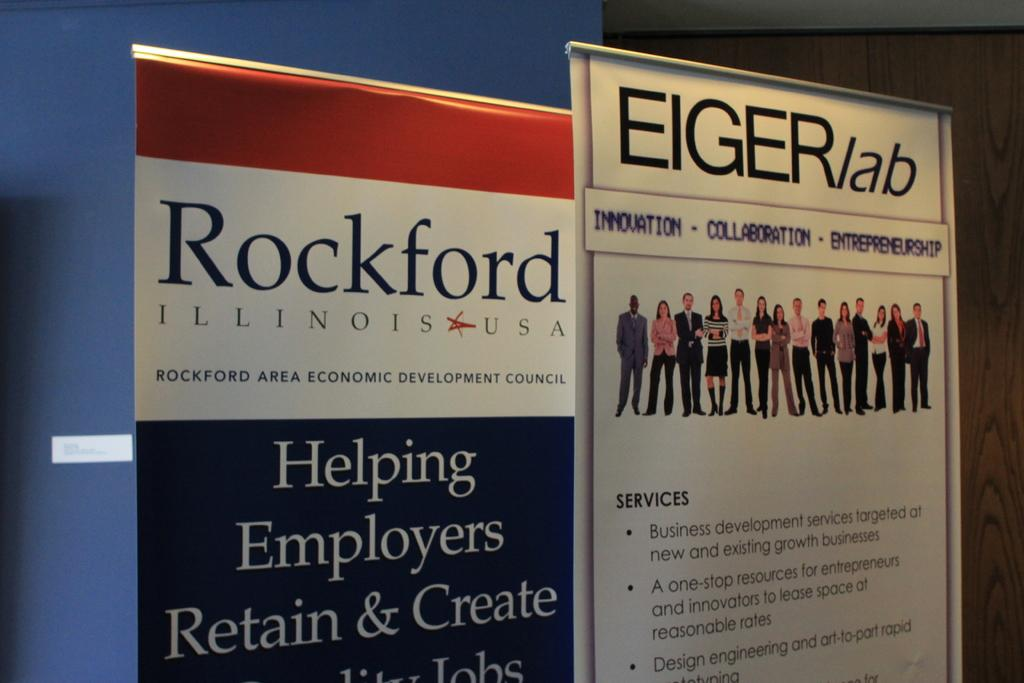Provide a one-sentence caption for the provided image. A Rockford Illinois economic development council poster sign. 